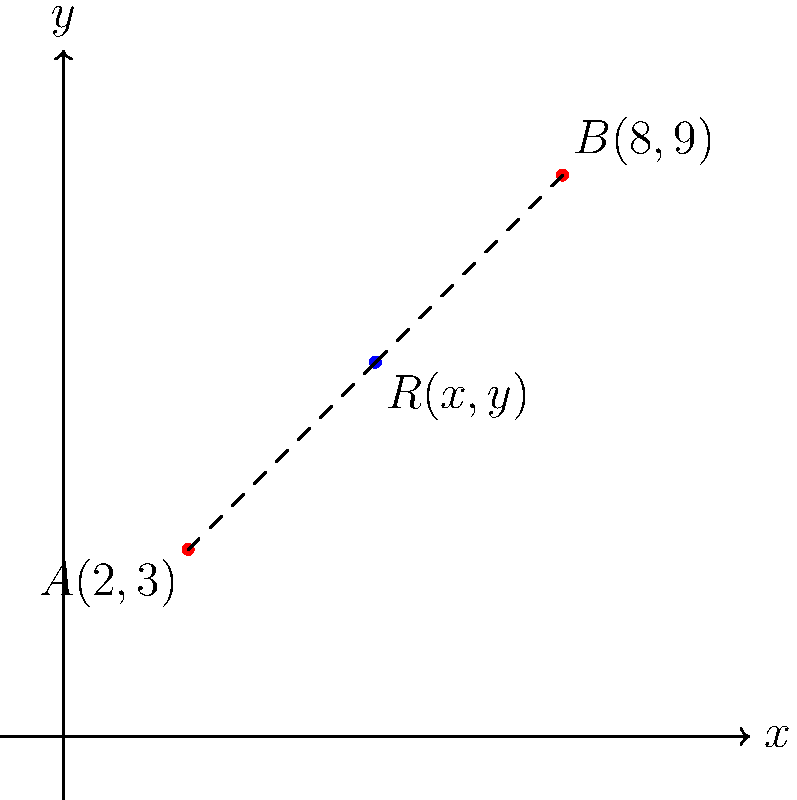In a quantum key distribution network, two nodes A(2,3) and B(8,9) need to be connected via a relay point R(x,y). To optimize the network's resilience against quantum attacks, the relay should be positioned such that the sum of its distances from A and B is minimized. Find the coordinates (x,y) of the optimal position for the relay R. To solve this optimization problem, we can follow these steps:

1) The distance between two points $(x_1,y_1)$ and $(x_2,y_2)$ is given by the formula:
   $$d = \sqrt{(x_2-x_1)^2 + (y_2-y_1)^2}$$

2) Let the relay point R have coordinates (x,y). The total distance D we want to minimize is:
   $$D = \sqrt{(x-2)^2 + (y-3)^2} + \sqrt{(x-8)^2 + (y-9)^2}$$

3) To minimize D, we need to find where its partial derivatives with respect to x and y are both zero:
   $$\frac{\partial D}{\partial x} = \frac{x-2}{\sqrt{(x-2)^2 + (y-3)^2}} + \frac{x-8}{\sqrt{(x-8)^2 + (y-9)^2}} = 0$$
   $$\frac{\partial D}{\partial y} = \frac{y-3}{\sqrt{(x-2)^2 + (y-3)^2}} + \frac{y-9}{\sqrt{(x-8)^2 + (y-9)^2}} = 0$$

4) These equations are satisfied when the two vectors (from R to A and from R to B) are equal and opposite, which occurs when R is on the straight line between A and B.

5) The line passing through A(2,3) and B(8,9) has the equation:
   $$y - 3 = \frac{9-3}{8-2}(x-2) = x-2$$
   $$y = x + 1$$

6) The midpoint of AB will satisfy this equation and minimize the total distance. The midpoint formula gives:
   $$x = \frac{2+8}{2} = 5$$
   $$y = \frac{3+9}{2} = 6$$

7) We can verify that this point (5,6) satisfies the line equation: 6 = 5 + 1

Therefore, the optimal position for the relay R is (5,6).
Answer: (5,6) 